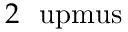Convert formula to latex. <formula><loc_0><loc_0><loc_500><loc_500>2 \ u p m u s</formula> 